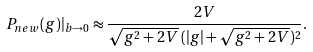<formula> <loc_0><loc_0><loc_500><loc_500>P _ { n e w } ( g ) | _ { b \to 0 } \approx \frac { 2 V } { \sqrt { g ^ { 2 } + 2 V } \, ( | g | + \sqrt { g ^ { 2 } + 2 V } ) ^ { 2 } } .</formula> 